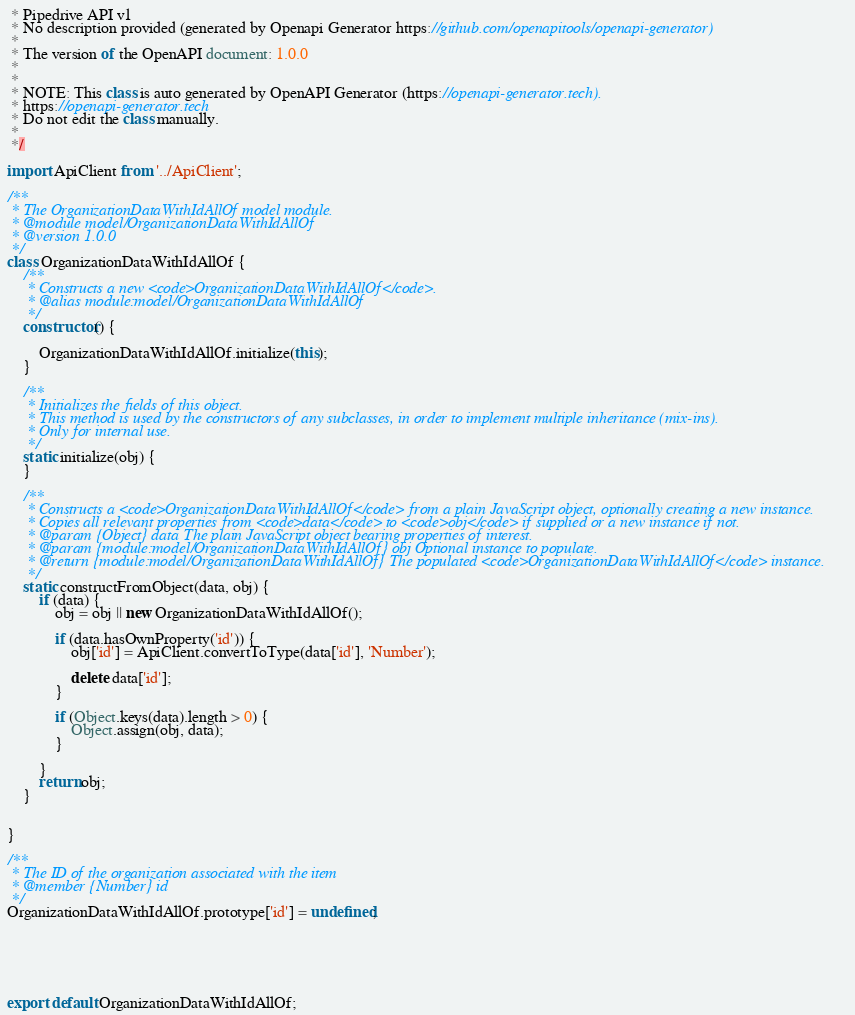<code> <loc_0><loc_0><loc_500><loc_500><_JavaScript_> * Pipedrive API v1
 * No description provided (generated by Openapi Generator https://github.com/openapitools/openapi-generator)
 *
 * The version of the OpenAPI document: 1.0.0
 * 
 *
 * NOTE: This class is auto generated by OpenAPI Generator (https://openapi-generator.tech).
 * https://openapi-generator.tech
 * Do not edit the class manually.
 *
 */

import ApiClient from '../ApiClient';

/**
 * The OrganizationDataWithIdAllOf model module.
 * @module model/OrganizationDataWithIdAllOf
 * @version 1.0.0
 */
class OrganizationDataWithIdAllOf {
    /**
     * Constructs a new <code>OrganizationDataWithIdAllOf</code>.
     * @alias module:model/OrganizationDataWithIdAllOf
     */
    constructor() { 
        
        OrganizationDataWithIdAllOf.initialize(this);
    }

    /**
     * Initializes the fields of this object.
     * This method is used by the constructors of any subclasses, in order to implement multiple inheritance (mix-ins).
     * Only for internal use.
     */
    static initialize(obj) { 
    }

    /**
     * Constructs a <code>OrganizationDataWithIdAllOf</code> from a plain JavaScript object, optionally creating a new instance.
     * Copies all relevant properties from <code>data</code> to <code>obj</code> if supplied or a new instance if not.
     * @param {Object} data The plain JavaScript object bearing properties of interest.
     * @param {module:model/OrganizationDataWithIdAllOf} obj Optional instance to populate.
     * @return {module:model/OrganizationDataWithIdAllOf} The populated <code>OrganizationDataWithIdAllOf</code> instance.
     */
    static constructFromObject(data, obj) {
        if (data) {
            obj = obj || new OrganizationDataWithIdAllOf();

            if (data.hasOwnProperty('id')) {
                obj['id'] = ApiClient.convertToType(data['id'], 'Number');

                delete data['id'];
            }

            if (Object.keys(data).length > 0) {
                Object.assign(obj, data);
            }

        }
        return obj;
    }


}

/**
 * The ID of the organization associated with the item
 * @member {Number} id
 */
OrganizationDataWithIdAllOf.prototype['id'] = undefined;






export default OrganizationDataWithIdAllOf;

</code> 